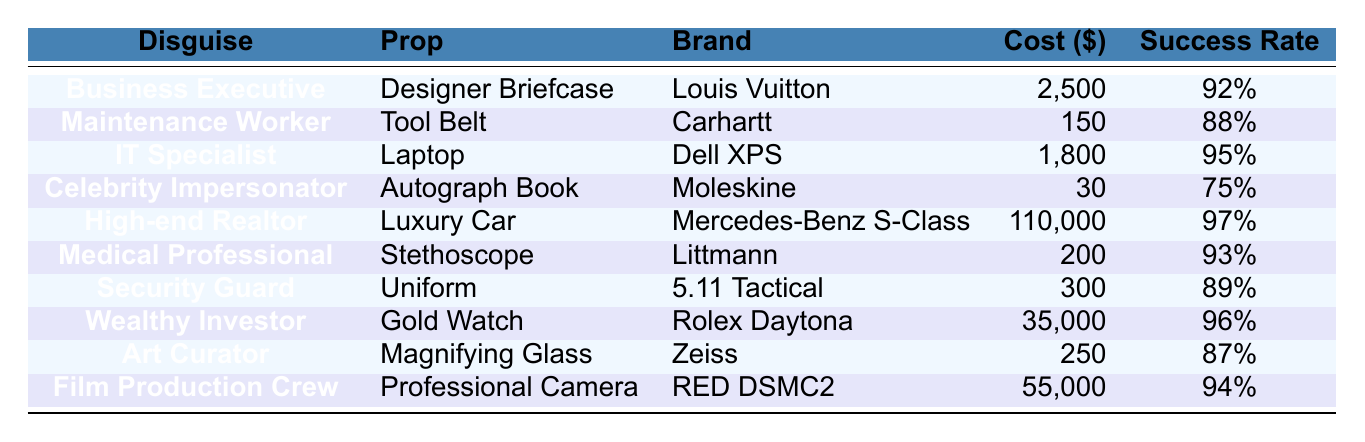What is the most expensive disguise in the table? The "High-end Realtor" disguise has a cost of $110,000, which is the highest among all entries in the table.
Answer: $110,000 Which disguise has the highest success rate? The "High-end Realtor" disguise has the highest success rate of 97%.
Answer: 97% What is the total cost of the props used for disguises? The total cost can be calculated by summing all individual costs: (2500 + 150 + 1800 + 30 + 110000 + 200 + 300 + 35000 + 250 + 55000) = $197,230.
Answer: $197,230 Is the success rate of the "Celebrity Impersonator" higher than that of the "Security Guard"? The "Celebrity Impersonator" has a success rate of 75%, while the "Security Guard" has a success rate of 89%. Therefore, the statement is false.
Answer: No What is the average cost of the disguises in the table? There are 10 disguises, and the total cost is $197,230, so the average cost is calculated as $197,230 / 10 = $19,723.
Answer: $19,723 Is there any disguise that costs more than $50,000? Yes, the "High-end Realtor" ($110,000) and "Film Production Crew" ($55,000) appear in the table, both costing more than $50,000.
Answer: Yes What is the difference in success rate between the "IT Specialist" and the "Art Curator"? The success rate of "IT Specialist" is 95% and that of "Art Curator" is 87%, so the difference is 95% - 87% = 8%.
Answer: 8% How many disguises have a success rate greater than 90%? The disguises with success rates greater than 90% are "Business Executive" (92%), "IT Specialist" (95%), "High-end Realtor" (97%), and "Medical Professional" (93%). Therefore, there are 4 such disguises.
Answer: 4 What prop is associated with the "Wealthy Investor"? The prop associated with the "Wealthy Investor" disguise is a "Gold Watch."
Answer: Gold Watch Which disguise has the lowest success rate? The disguise with the lowest success rate is the "Celebrity Impersonator," which has a success rate of 75%.
Answer: 75% 